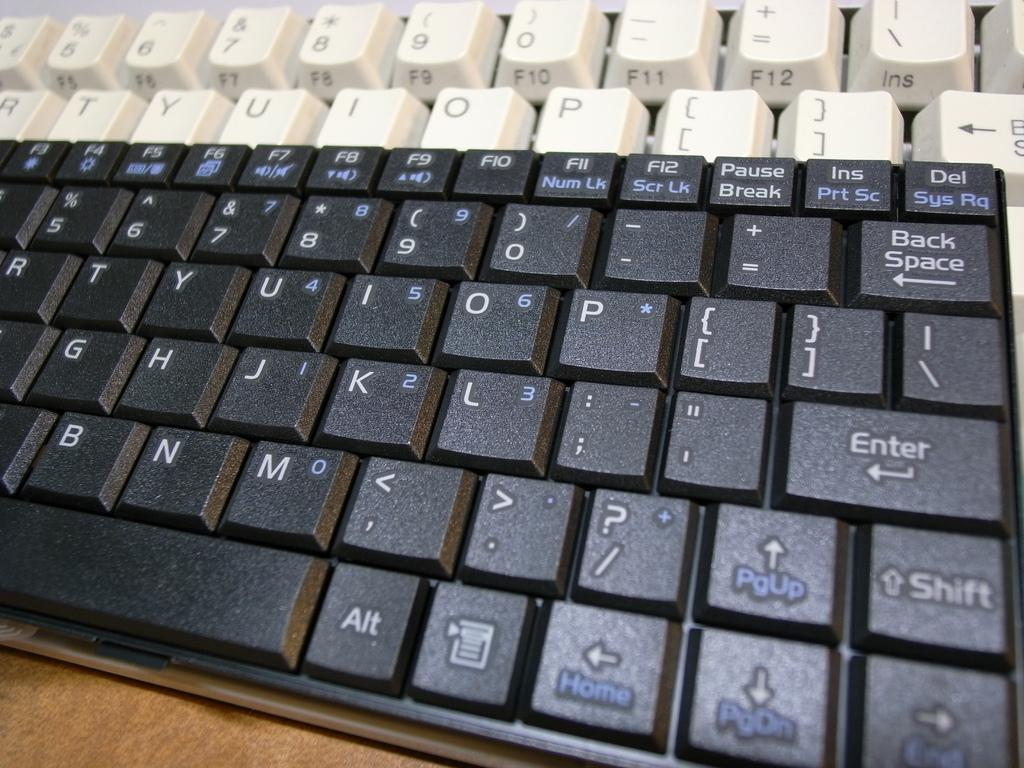<image>
Write a terse but informative summary of the picture. Two computer keyboard where the visible keys include Alt, Home Enter, Del, etc.. 